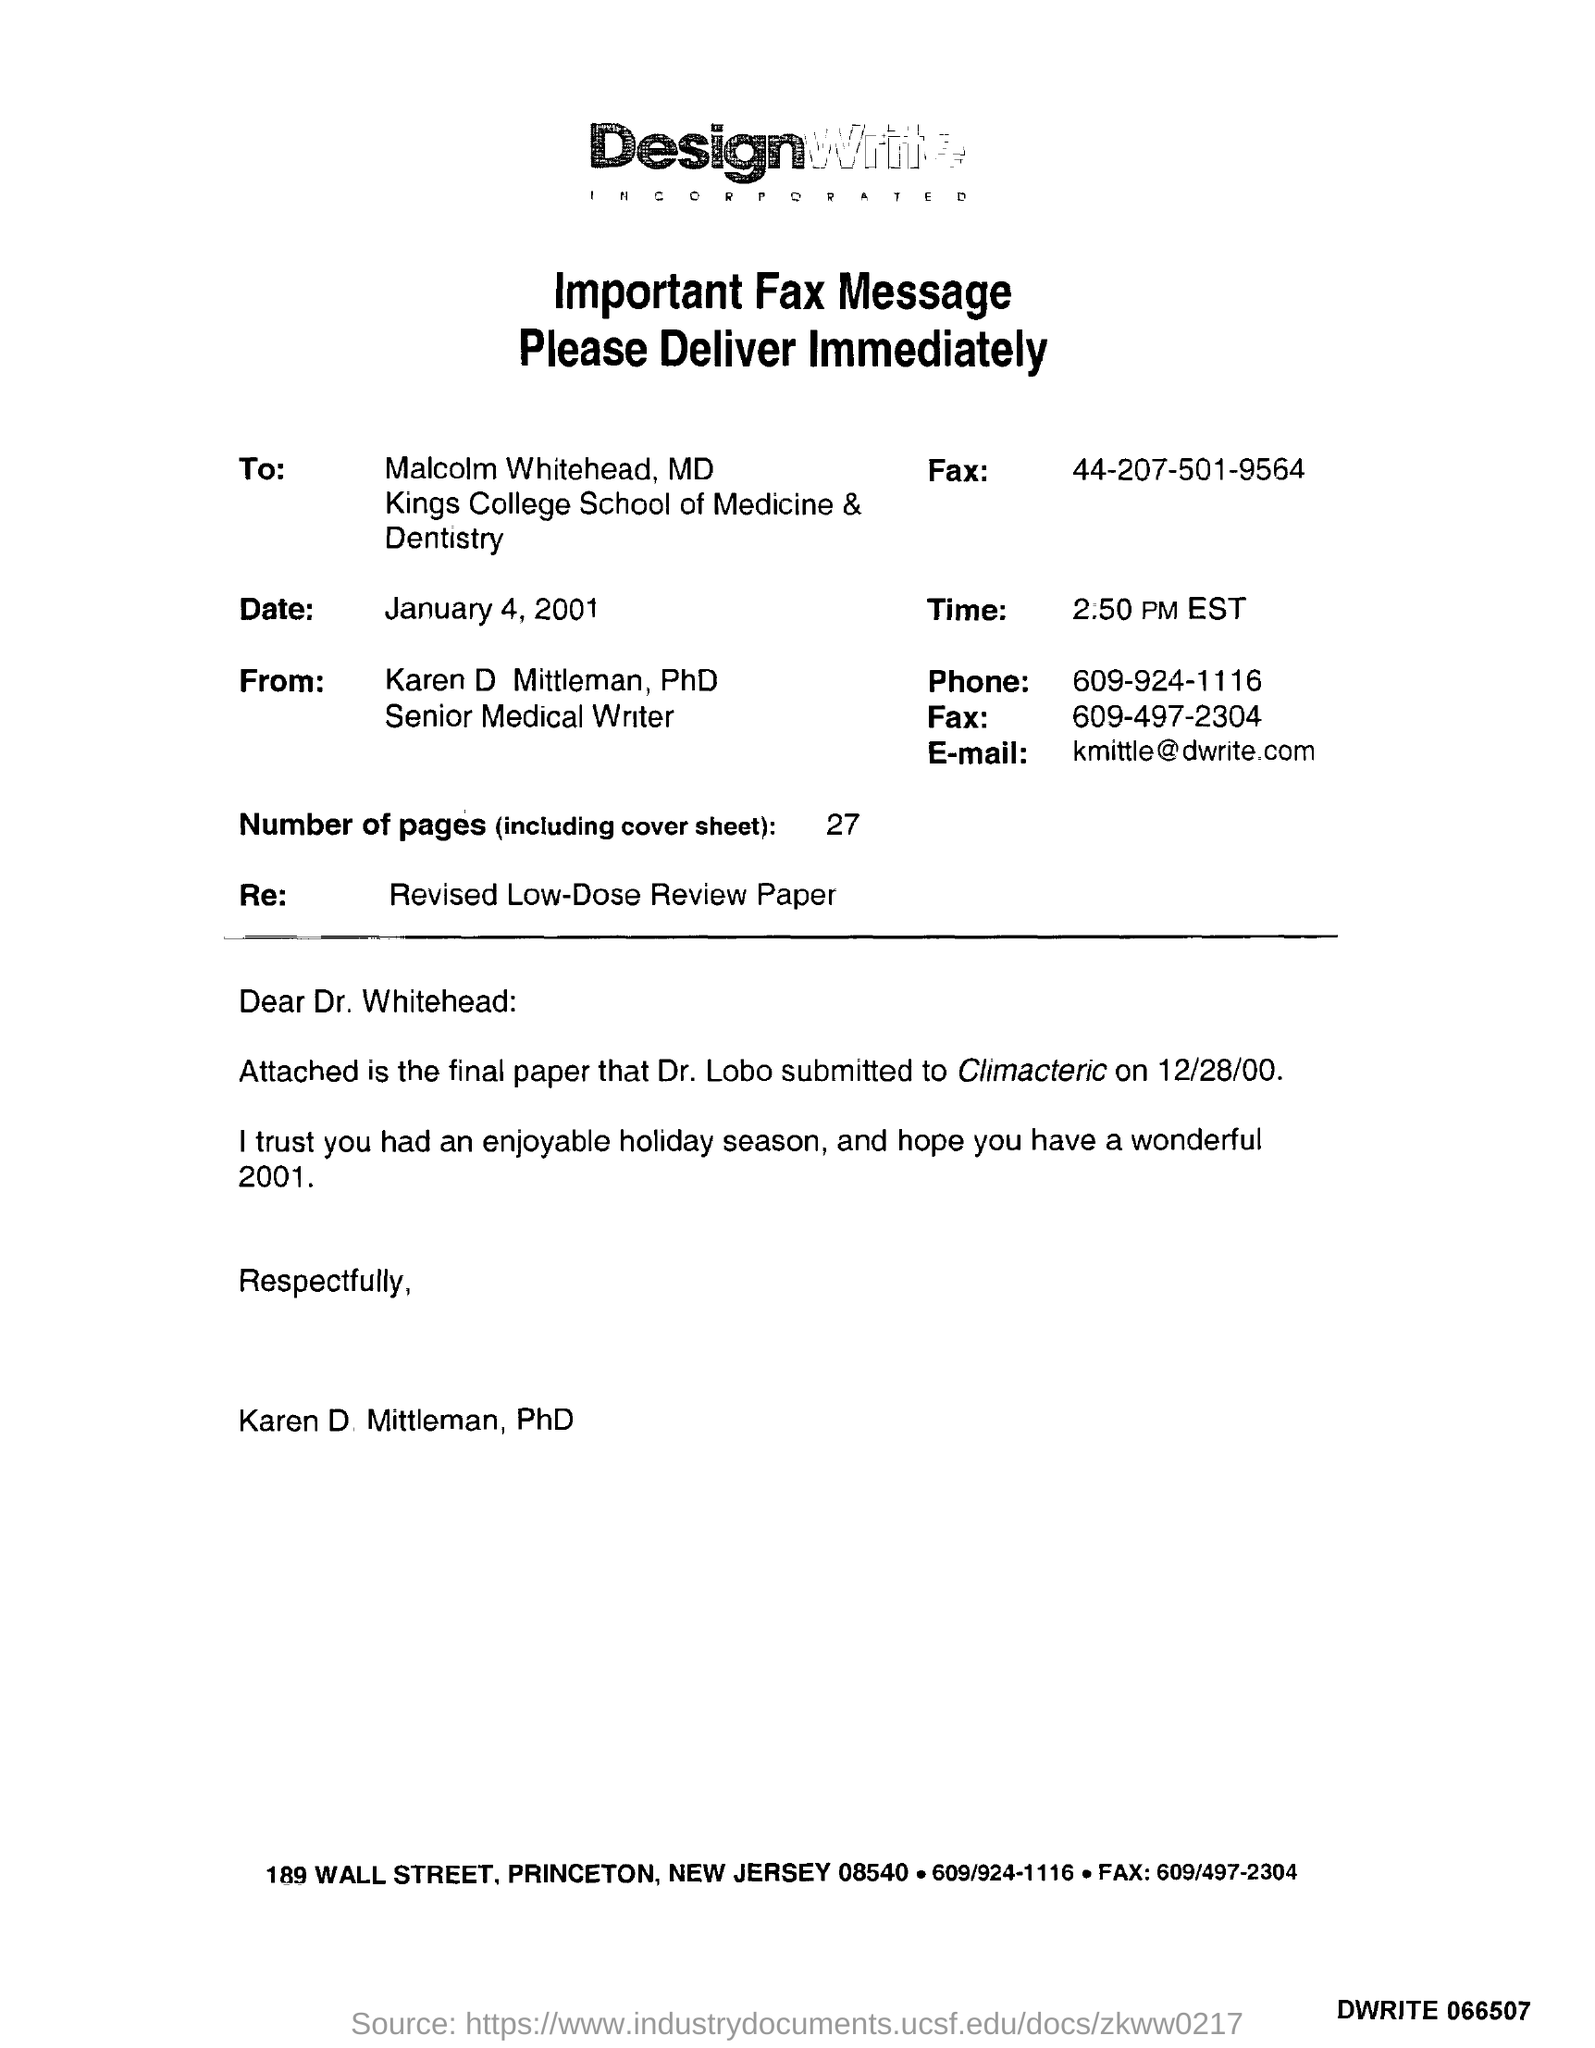Identify some key points in this picture. The phone number of a Senior Medical Writer is 609-924-1116. The fax message was sent on January 4, 2001. 